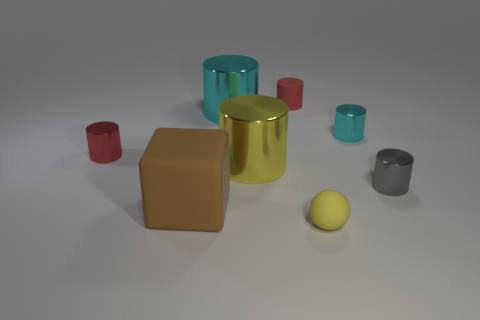Is there anything else that is the same shape as the big brown object?
Keep it short and to the point. No. There is a shiny object that is the same color as the matte sphere; what is its shape?
Make the answer very short. Cylinder. Are there any tiny red rubber things of the same shape as the brown rubber thing?
Your response must be concise. No. Is the number of gray cylinders that are to the left of the tiny cyan shiny thing less than the number of tiny objects on the left side of the gray object?
Provide a short and direct response. Yes. What is the color of the rubber cylinder?
Provide a succinct answer. Red. Are there any red metal objects that are behind the metallic object that is on the left side of the brown matte block?
Provide a succinct answer. No. What number of purple objects have the same size as the yellow metal cylinder?
Offer a very short reply. 0. There is a small matte object behind the tiny matte object in front of the matte block; what number of small red shiny objects are in front of it?
Ensure brevity in your answer.  1. How many metal cylinders are to the right of the rubber cube and to the left of the sphere?
Offer a terse response. 2. Are there any other things of the same color as the cube?
Give a very brief answer. No. 